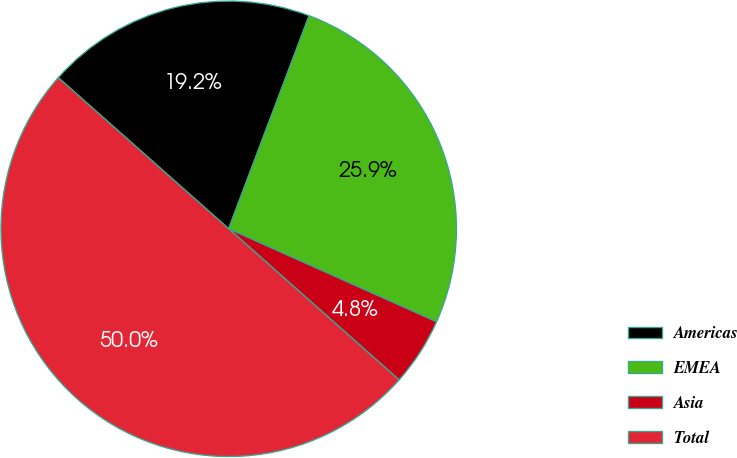<chart> <loc_0><loc_0><loc_500><loc_500><pie_chart><fcel>Americas<fcel>EMEA<fcel>Asia<fcel>Total<nl><fcel>19.2%<fcel>25.95%<fcel>4.85%<fcel>50.0%<nl></chart> 